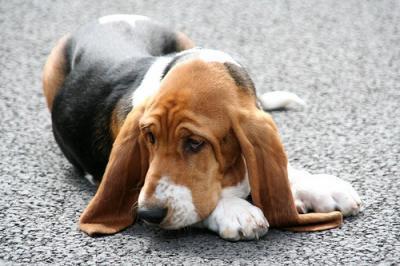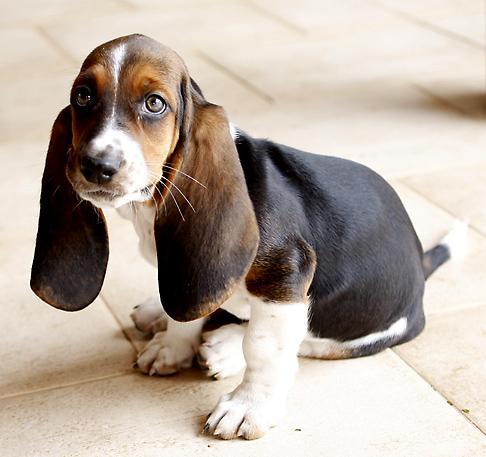The first image is the image on the left, the second image is the image on the right. For the images displayed, is the sentence "One dog is reclining and one is sitting, and there are only two animals in total." factually correct? Answer yes or no. Yes. The first image is the image on the left, the second image is the image on the right. For the images shown, is this caption "The right image shows a single dog sitting." true? Answer yes or no. Yes. 